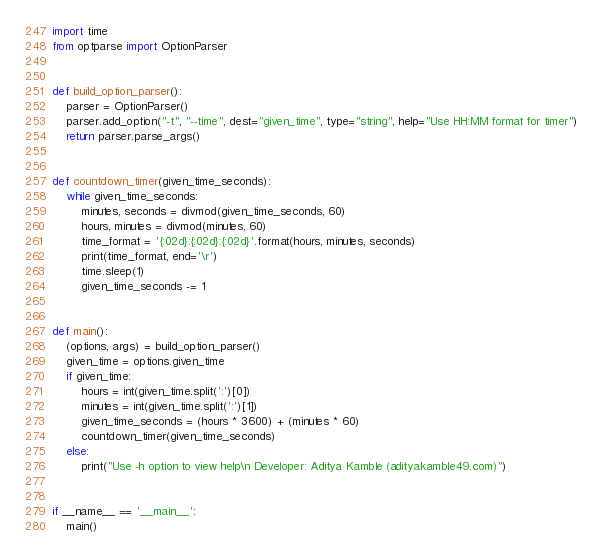<code> <loc_0><loc_0><loc_500><loc_500><_Python_>import time
from optparse import OptionParser


def build_option_parser():
    parser = OptionParser()
    parser.add_option("-t", "--time", dest="given_time", type="string", help="Use HH:MM format for timer")
    return parser.parse_args()


def countdown_timer(given_time_seconds):
    while given_time_seconds:
        minutes, seconds = divmod(given_time_seconds, 60)
        hours, minutes = divmod(minutes, 60)
        time_format = '{:02d}:{:02d}:{:02d}'.format(hours, minutes, seconds)
        print(time_format, end='\r')
        time.sleep(1)
        given_time_seconds -= 1


def main():
    (options, args) = build_option_parser()
    given_time = options.given_time
    if given_time:
        hours = int(given_time.split(':')[0])
        minutes = int(given_time.split(':')[1])
        given_time_seconds = (hours * 3600) + (minutes * 60)
        countdown_timer(given_time_seconds)
    else:
        print("Use -h option to view help\n Developer: Aditya Kamble (adityakamble49.com)")


if __name__ == '__main__':
    main()
</code> 